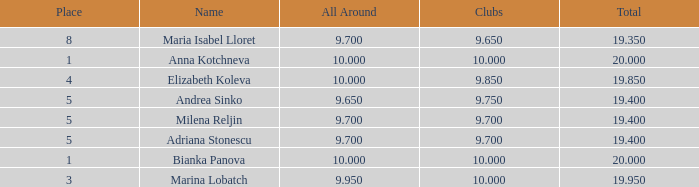What is the highest total that has andrea sinko as the name, with an all around greater than 9.65? None. 